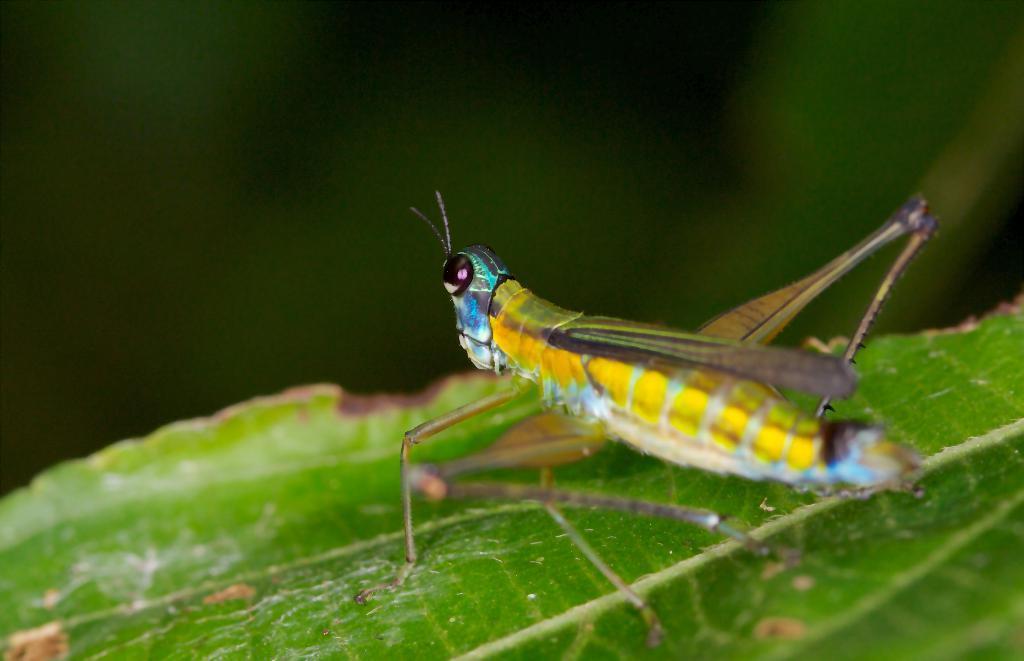Could you give a brief overview of what you see in this image? In this image we can see there is an insect on the leaf. 